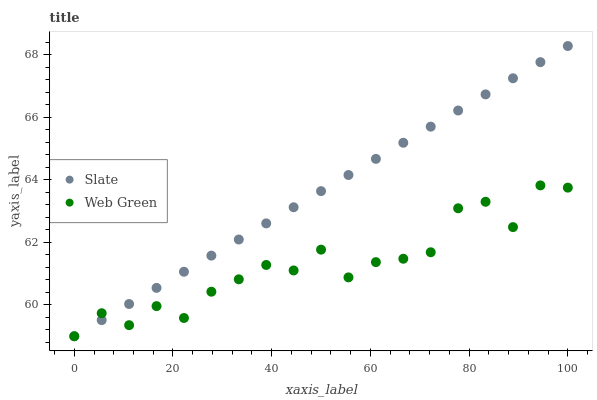Does Web Green have the minimum area under the curve?
Answer yes or no. Yes. Does Slate have the maximum area under the curve?
Answer yes or no. Yes. Does Web Green have the maximum area under the curve?
Answer yes or no. No. Is Slate the smoothest?
Answer yes or no. Yes. Is Web Green the roughest?
Answer yes or no. Yes. Is Web Green the smoothest?
Answer yes or no. No. Does Slate have the lowest value?
Answer yes or no. Yes. Does Slate have the highest value?
Answer yes or no. Yes. Does Web Green have the highest value?
Answer yes or no. No. Does Slate intersect Web Green?
Answer yes or no. Yes. Is Slate less than Web Green?
Answer yes or no. No. Is Slate greater than Web Green?
Answer yes or no. No. 